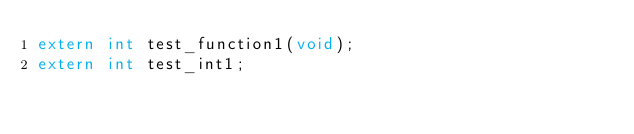Convert code to text. <code><loc_0><loc_0><loc_500><loc_500><_C_>extern int test_function1(void);
extern int test_int1;</code> 